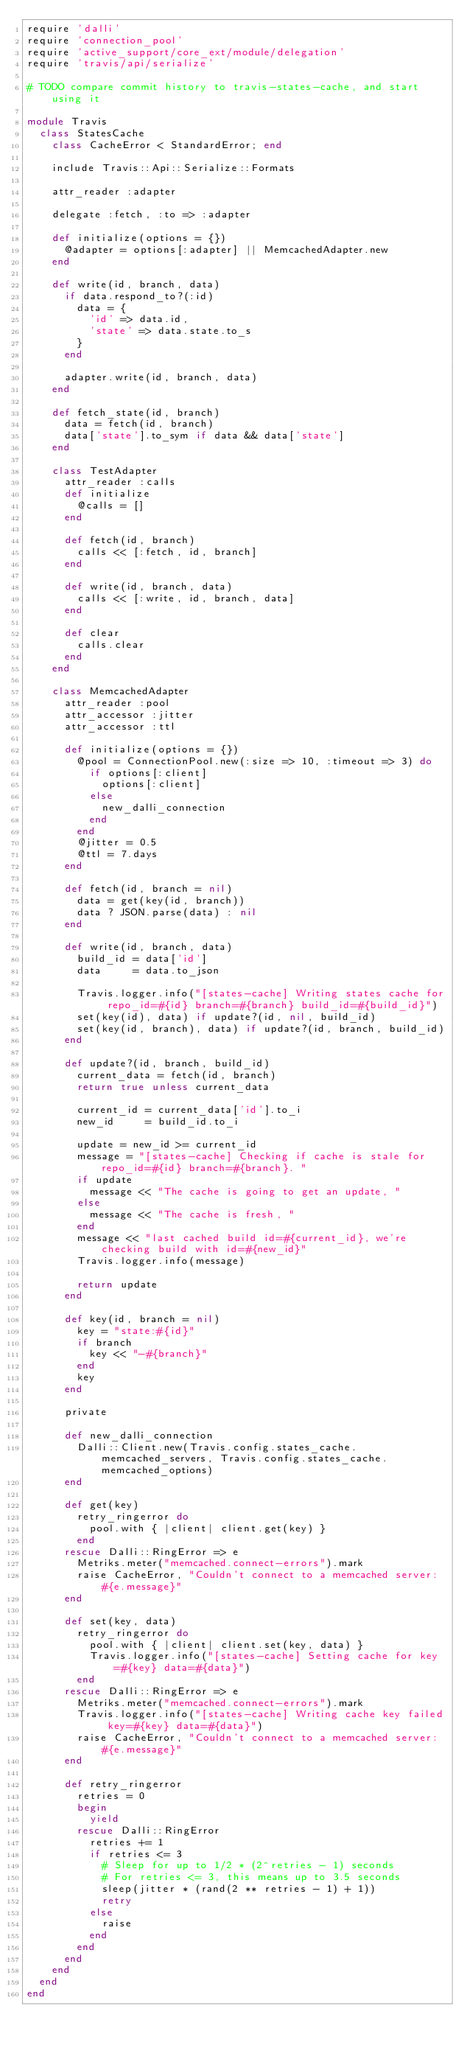<code> <loc_0><loc_0><loc_500><loc_500><_Ruby_>require 'dalli'
require 'connection_pool'
require 'active_support/core_ext/module/delegation'
require 'travis/api/serialize'

# TODO compare commit history to travis-states-cache, and start using it

module Travis
  class StatesCache
    class CacheError < StandardError; end

    include Travis::Api::Serialize::Formats

    attr_reader :adapter

    delegate :fetch, :to => :adapter

    def initialize(options = {})
      @adapter = options[:adapter] || MemcachedAdapter.new
    end

    def write(id, branch, data)
      if data.respond_to?(:id)
        data = {
          'id' => data.id,
          'state' => data.state.to_s
        }
      end

      adapter.write(id, branch, data)
    end

    def fetch_state(id, branch)
      data = fetch(id, branch)
      data['state'].to_sym if data && data['state']
    end

    class TestAdapter
      attr_reader :calls
      def initialize
        @calls = []
      end

      def fetch(id, branch)
        calls << [:fetch, id, branch]
      end

      def write(id, branch, data)
        calls << [:write, id, branch, data]
      end

      def clear
        calls.clear
      end
    end

    class MemcachedAdapter
      attr_reader :pool
      attr_accessor :jitter
      attr_accessor :ttl

      def initialize(options = {})
        @pool = ConnectionPool.new(:size => 10, :timeout => 3) do
          if options[:client]
            options[:client]
          else
            new_dalli_connection
          end
        end
        @jitter = 0.5
        @ttl = 7.days
      end

      def fetch(id, branch = nil)
        data = get(key(id, branch))
        data ? JSON.parse(data) : nil
      end

      def write(id, branch, data)
        build_id = data['id']
        data     = data.to_json

        Travis.logger.info("[states-cache] Writing states cache for repo_id=#{id} branch=#{branch} build_id=#{build_id}")
        set(key(id), data) if update?(id, nil, build_id)
        set(key(id, branch), data) if update?(id, branch, build_id)
      end

      def update?(id, branch, build_id)
        current_data = fetch(id, branch)
        return true unless current_data

        current_id = current_data['id'].to_i
        new_id     = build_id.to_i

        update = new_id >= current_id
        message = "[states-cache] Checking if cache is stale for repo_id=#{id} branch=#{branch}. "
        if update
          message << "The cache is going to get an update, "
        else
          message << "The cache is fresh, "
        end
        message << "last cached build id=#{current_id}, we're checking build with id=#{new_id}"
        Travis.logger.info(message)

        return update
      end

      def key(id, branch = nil)
        key = "state:#{id}"
        if branch
          key << "-#{branch}"
        end
        key
      end

      private

      def new_dalli_connection
        Dalli::Client.new(Travis.config.states_cache.memcached_servers, Travis.config.states_cache.memcached_options)
      end

      def get(key)
        retry_ringerror do
          pool.with { |client| client.get(key) }
        end
      rescue Dalli::RingError => e
        Metriks.meter("memcached.connect-errors").mark
        raise CacheError, "Couldn't connect to a memcached server: #{e.message}"
      end

      def set(key, data)
        retry_ringerror do
          pool.with { |client| client.set(key, data) }
          Travis.logger.info("[states-cache] Setting cache for key=#{key} data=#{data}")
        end
      rescue Dalli::RingError => e
        Metriks.meter("memcached.connect-errors").mark
        Travis.logger.info("[states-cache] Writing cache key failed key=#{key} data=#{data}")
        raise CacheError, "Couldn't connect to a memcached server: #{e.message}"
      end

      def retry_ringerror
        retries = 0
        begin
          yield
        rescue Dalli::RingError
          retries += 1
          if retries <= 3
            # Sleep for up to 1/2 * (2^retries - 1) seconds
            # For retries <= 3, this means up to 3.5 seconds
            sleep(jitter * (rand(2 ** retries - 1) + 1))
            retry
          else
            raise
          end
        end
      end
    end
  end
end
</code> 